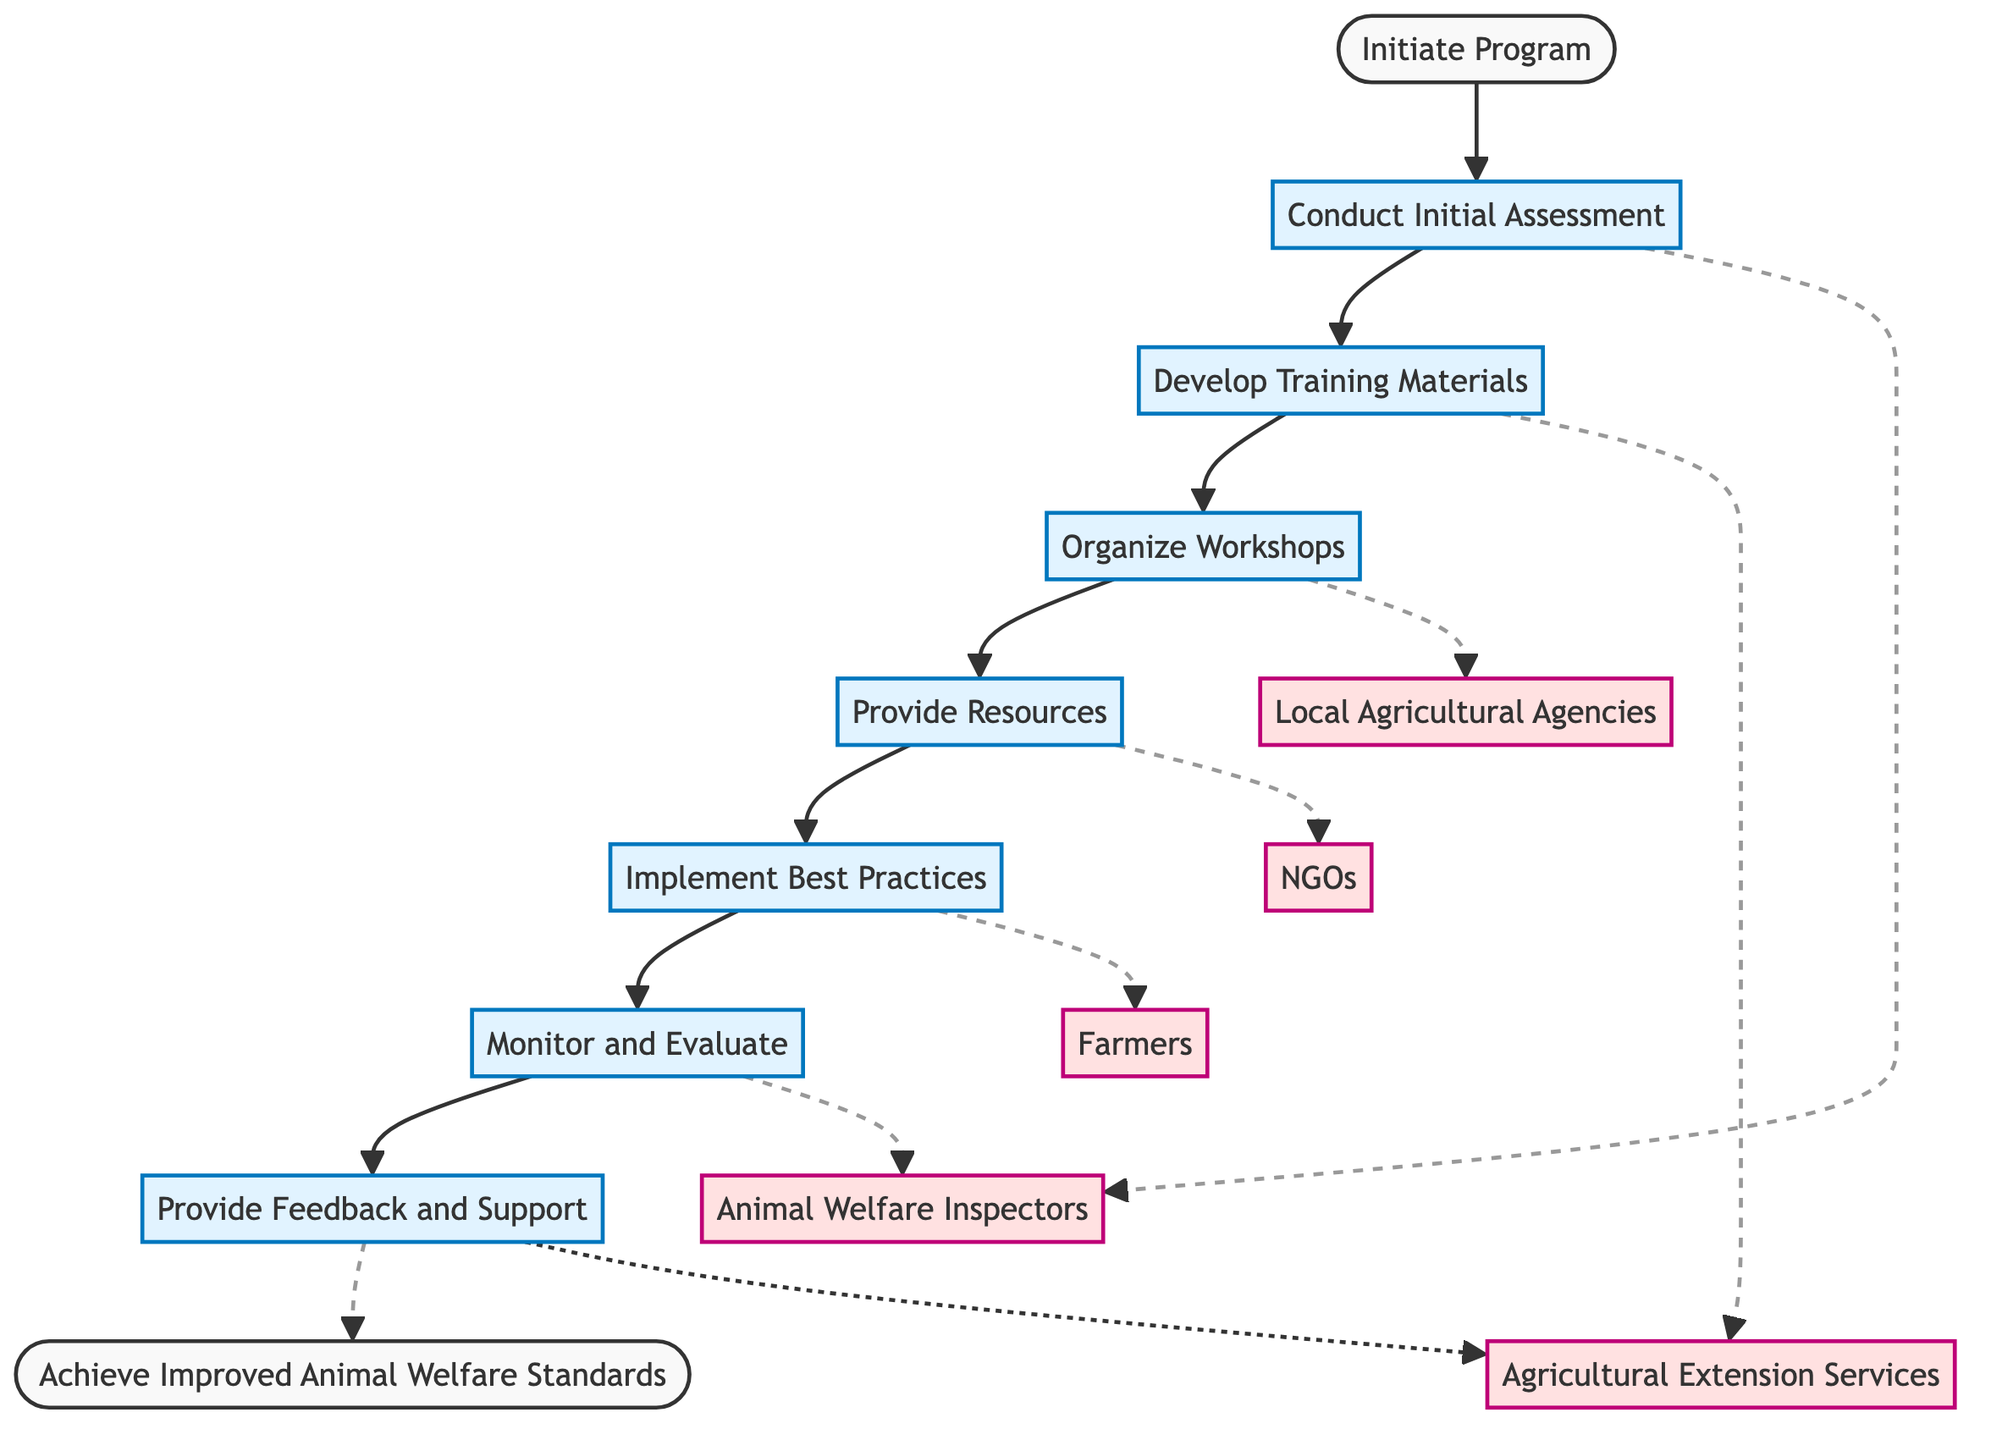What is the first step in the workflow? The diagram shows that the first step is "Conduct Initial Assessment", which follows directly from the "Initiate Program" node.
Answer: Conduct Initial Assessment Who is responsible for conducting the initial assessment? According to the diagram, the responsible entity for the initial assessment is "Animal Welfare Inspectors".
Answer: Animal Welfare Inspectors How many steps are there in the workflow? By counting the steps listed in the diagram, there are a total of seven steps from "Conduct Initial Assessment" to "Provide Feedback and Support".
Answer: Seven What action is associated with Step 4? The diagram indicates that the action for Step 4, which is titled "Provide Resources", is to distribute educational materials and toolkits to farmers.
Answer: Distribute educational materials and toolkits Which organization is responsible for providing feedback and support? The diagram states that "Agricultural Extension Services" is the entity responsible for providing feedback and support in Step 7.
Answer: Agricultural Extension Services What follows after "Organize Workshops"? The flow of the diagram shows that after "Organize Workshops", the next step is "Provide Resources".
Answer: Provide Resources What is the last step leading to improved animal welfare standards? The final step in the workflow before achieving the end goal is "Provide Feedback and Support" as indicated in the flowchart.
Answer: Provide Feedback and Support Which entities are responsible for monitoring and evaluating the practices? According to the diagram, "Animal Welfare Inspectors" are responsible for monitoring and evaluating the adherence to practices and assessing improvements.
Answer: Animal Welfare Inspectors 